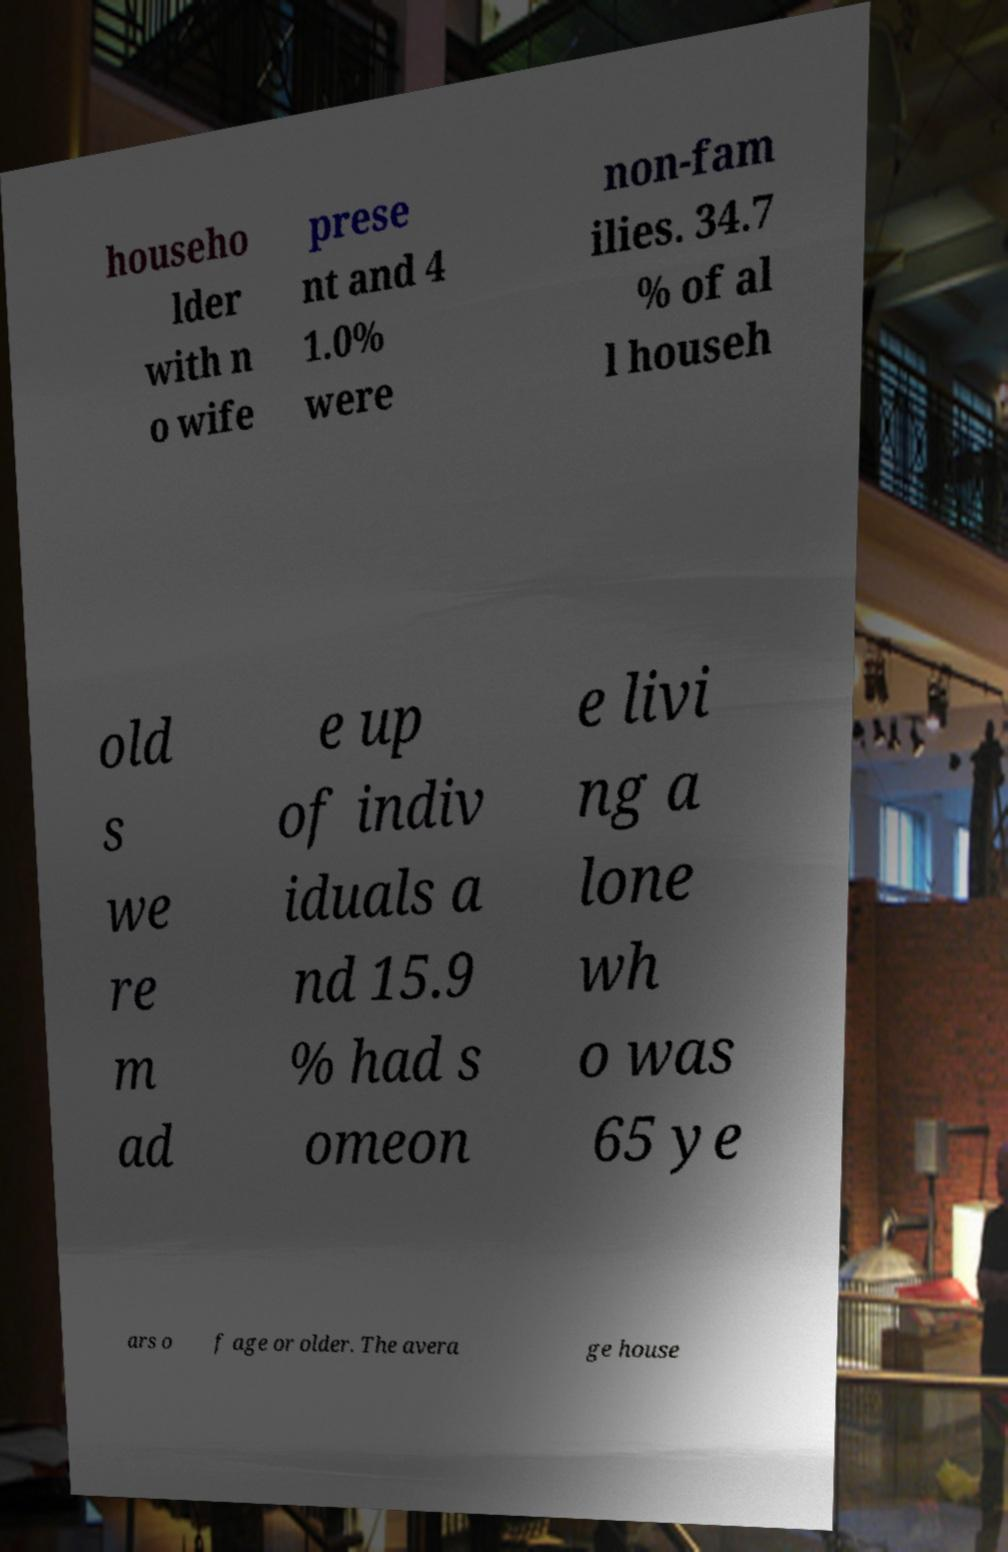Please identify and transcribe the text found in this image. househo lder with n o wife prese nt and 4 1.0% were non-fam ilies. 34.7 % of al l househ old s we re m ad e up of indiv iduals a nd 15.9 % had s omeon e livi ng a lone wh o was 65 ye ars o f age or older. The avera ge house 